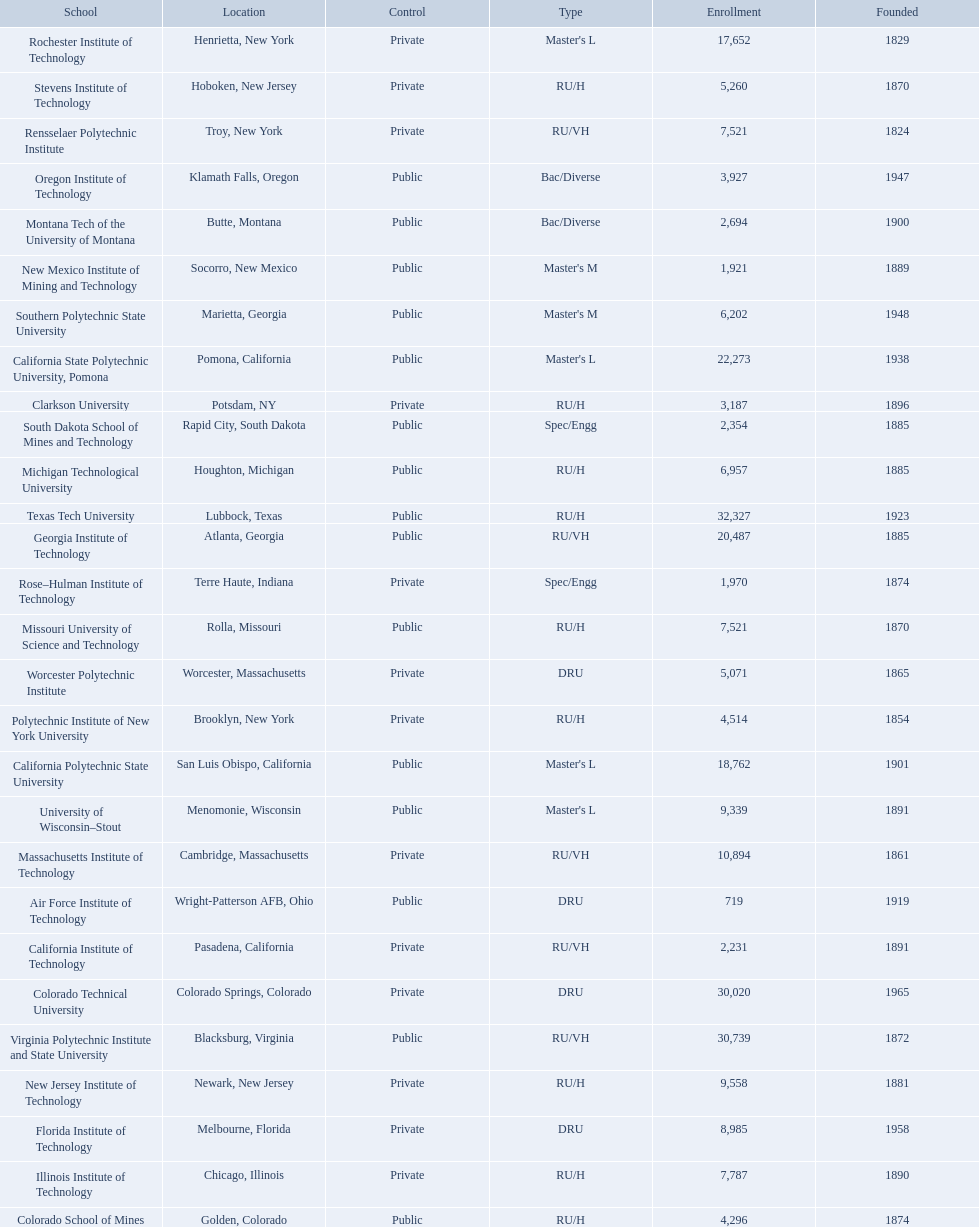What technical universities are in the united states? Air Force Institute of Technology, California Institute of Technology, California Polytechnic State University, California State Polytechnic University, Pomona, Clarkson University, Colorado School of Mines, Colorado Technical University, Florida Institute of Technology, Georgia Institute of Technology, Illinois Institute of Technology, Massachusetts Institute of Technology, Michigan Technological University, Missouri University of Science and Technology, Montana Tech of the University of Montana, New Jersey Institute of Technology, New Mexico Institute of Mining and Technology, Oregon Institute of Technology, Polytechnic Institute of New York University, Rensselaer Polytechnic Institute, Rochester Institute of Technology, Rose–Hulman Institute of Technology, South Dakota School of Mines and Technology, Southern Polytechnic State University, Stevens Institute of Technology, Texas Tech University, University of Wisconsin–Stout, Virginia Polytechnic Institute and State University, Worcester Polytechnic Institute. Which has the highest enrollment? Texas Tech University. 